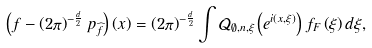Convert formula to latex. <formula><loc_0><loc_0><loc_500><loc_500>\left ( f - \left ( 2 \pi \right ) ^ { - \frac { d } { 2 } } p _ { \widehat { f } } \right ) \left ( x \right ) = \left ( 2 \pi \right ) ^ { - \frac { d } { 2 } } \int \mathcal { Q } _ { \emptyset , n , \xi } \left ( e ^ { i \left ( x , \xi \right ) } \right ) f _ { F } \left ( \xi \right ) d \xi ,</formula> 